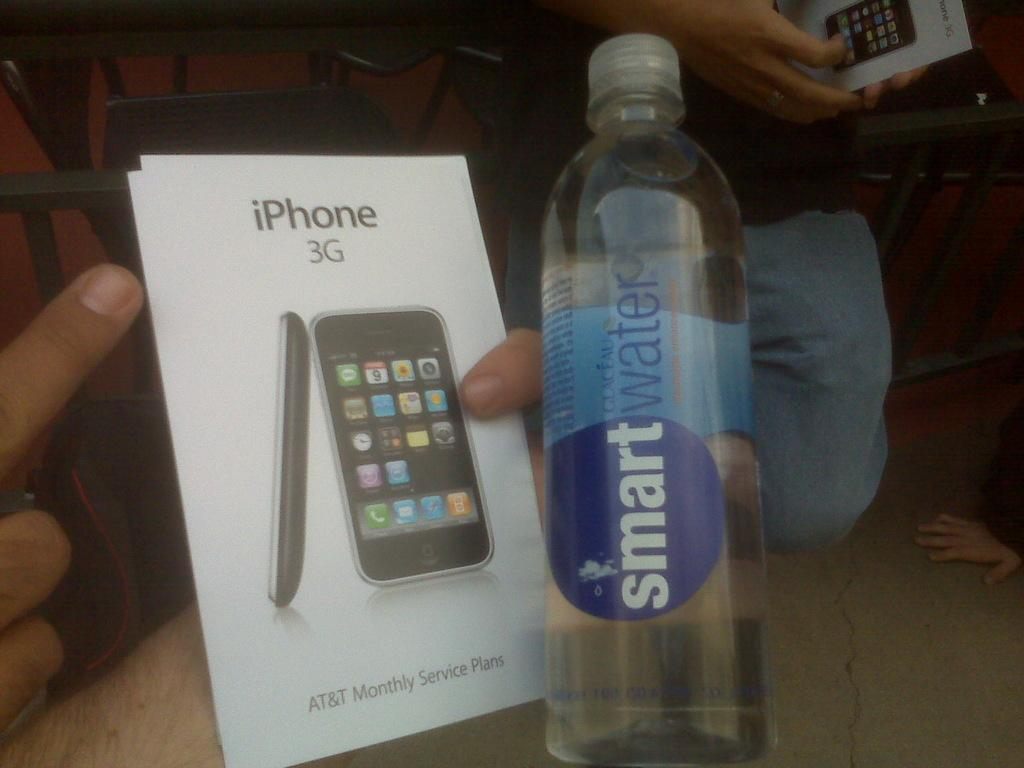Provide a one-sentence caption for the provided image. some smart water next to an iPhone booklet. 